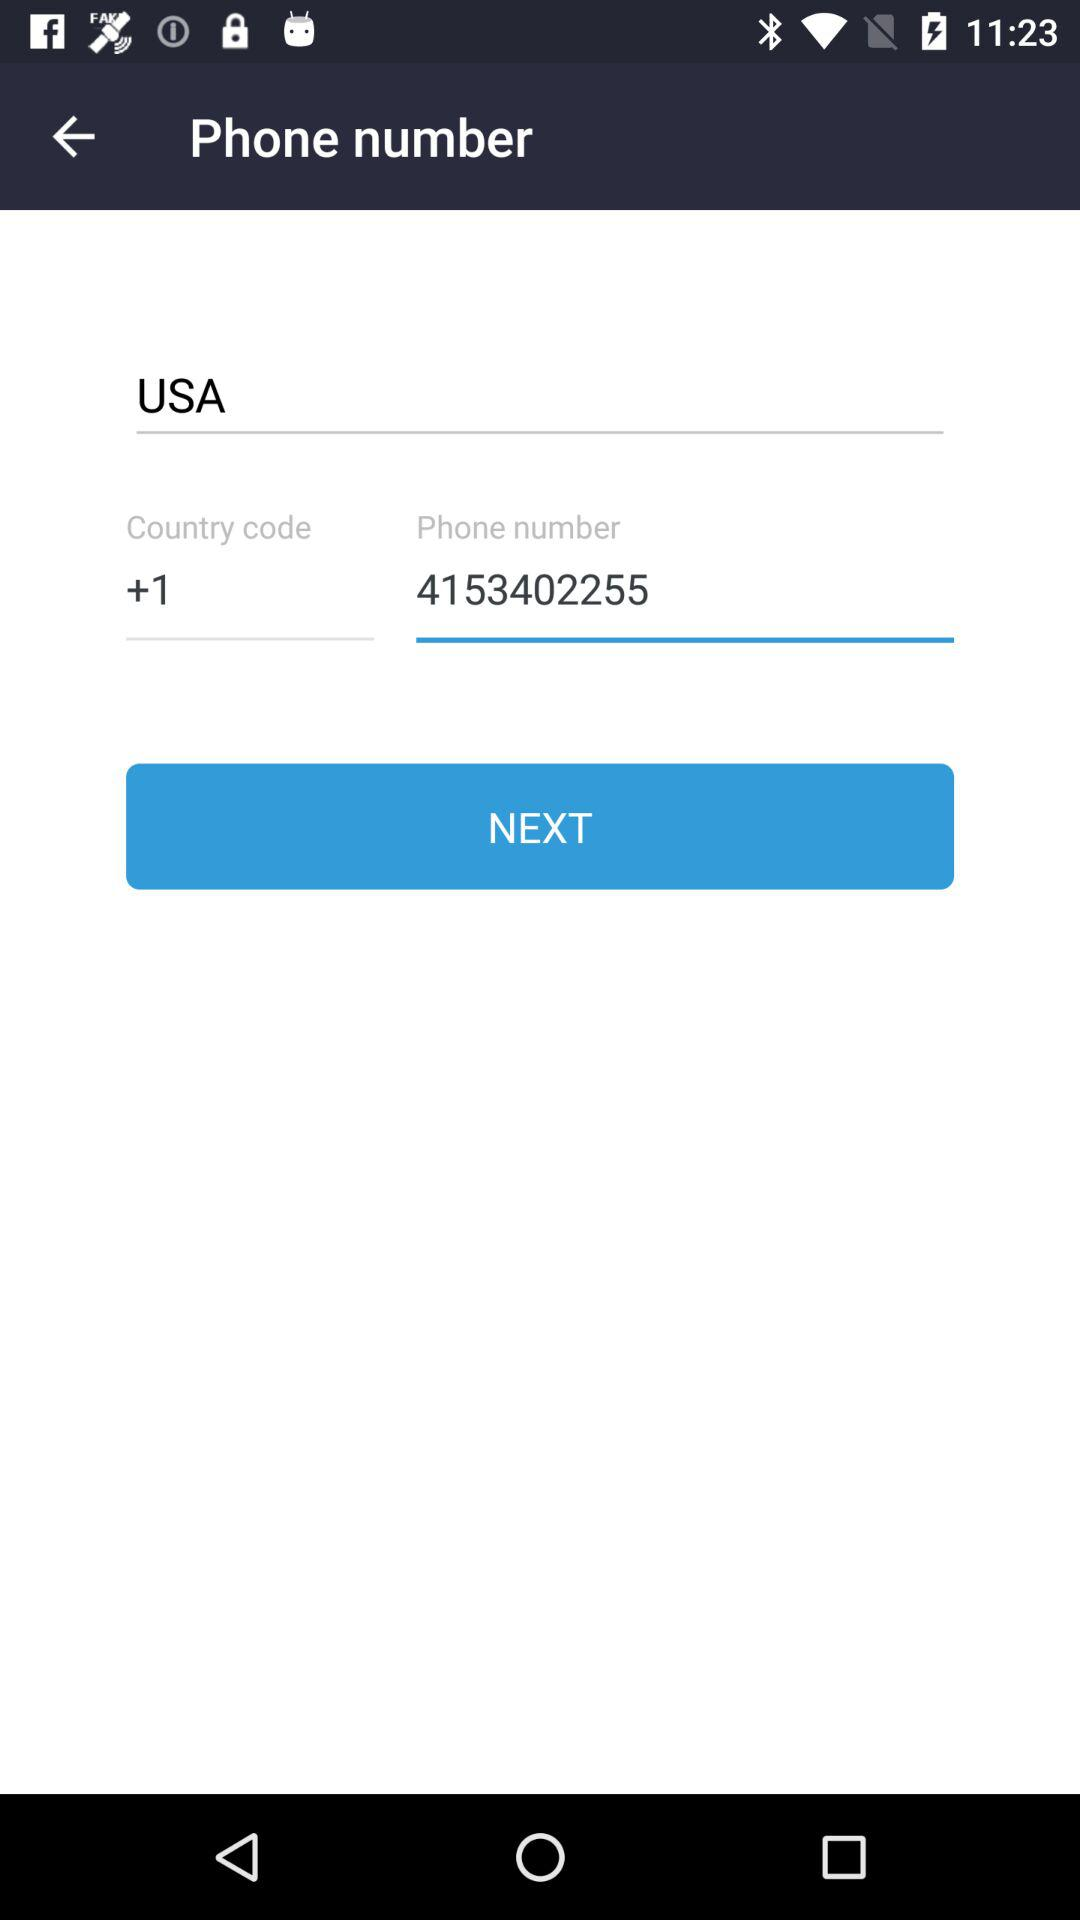What is the phone number? The phone number is 4153402255. 